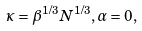<formula> <loc_0><loc_0><loc_500><loc_500>\kappa = \beta ^ { 1 / 3 } N ^ { 1 / 3 } , \alpha = 0 ,</formula> 